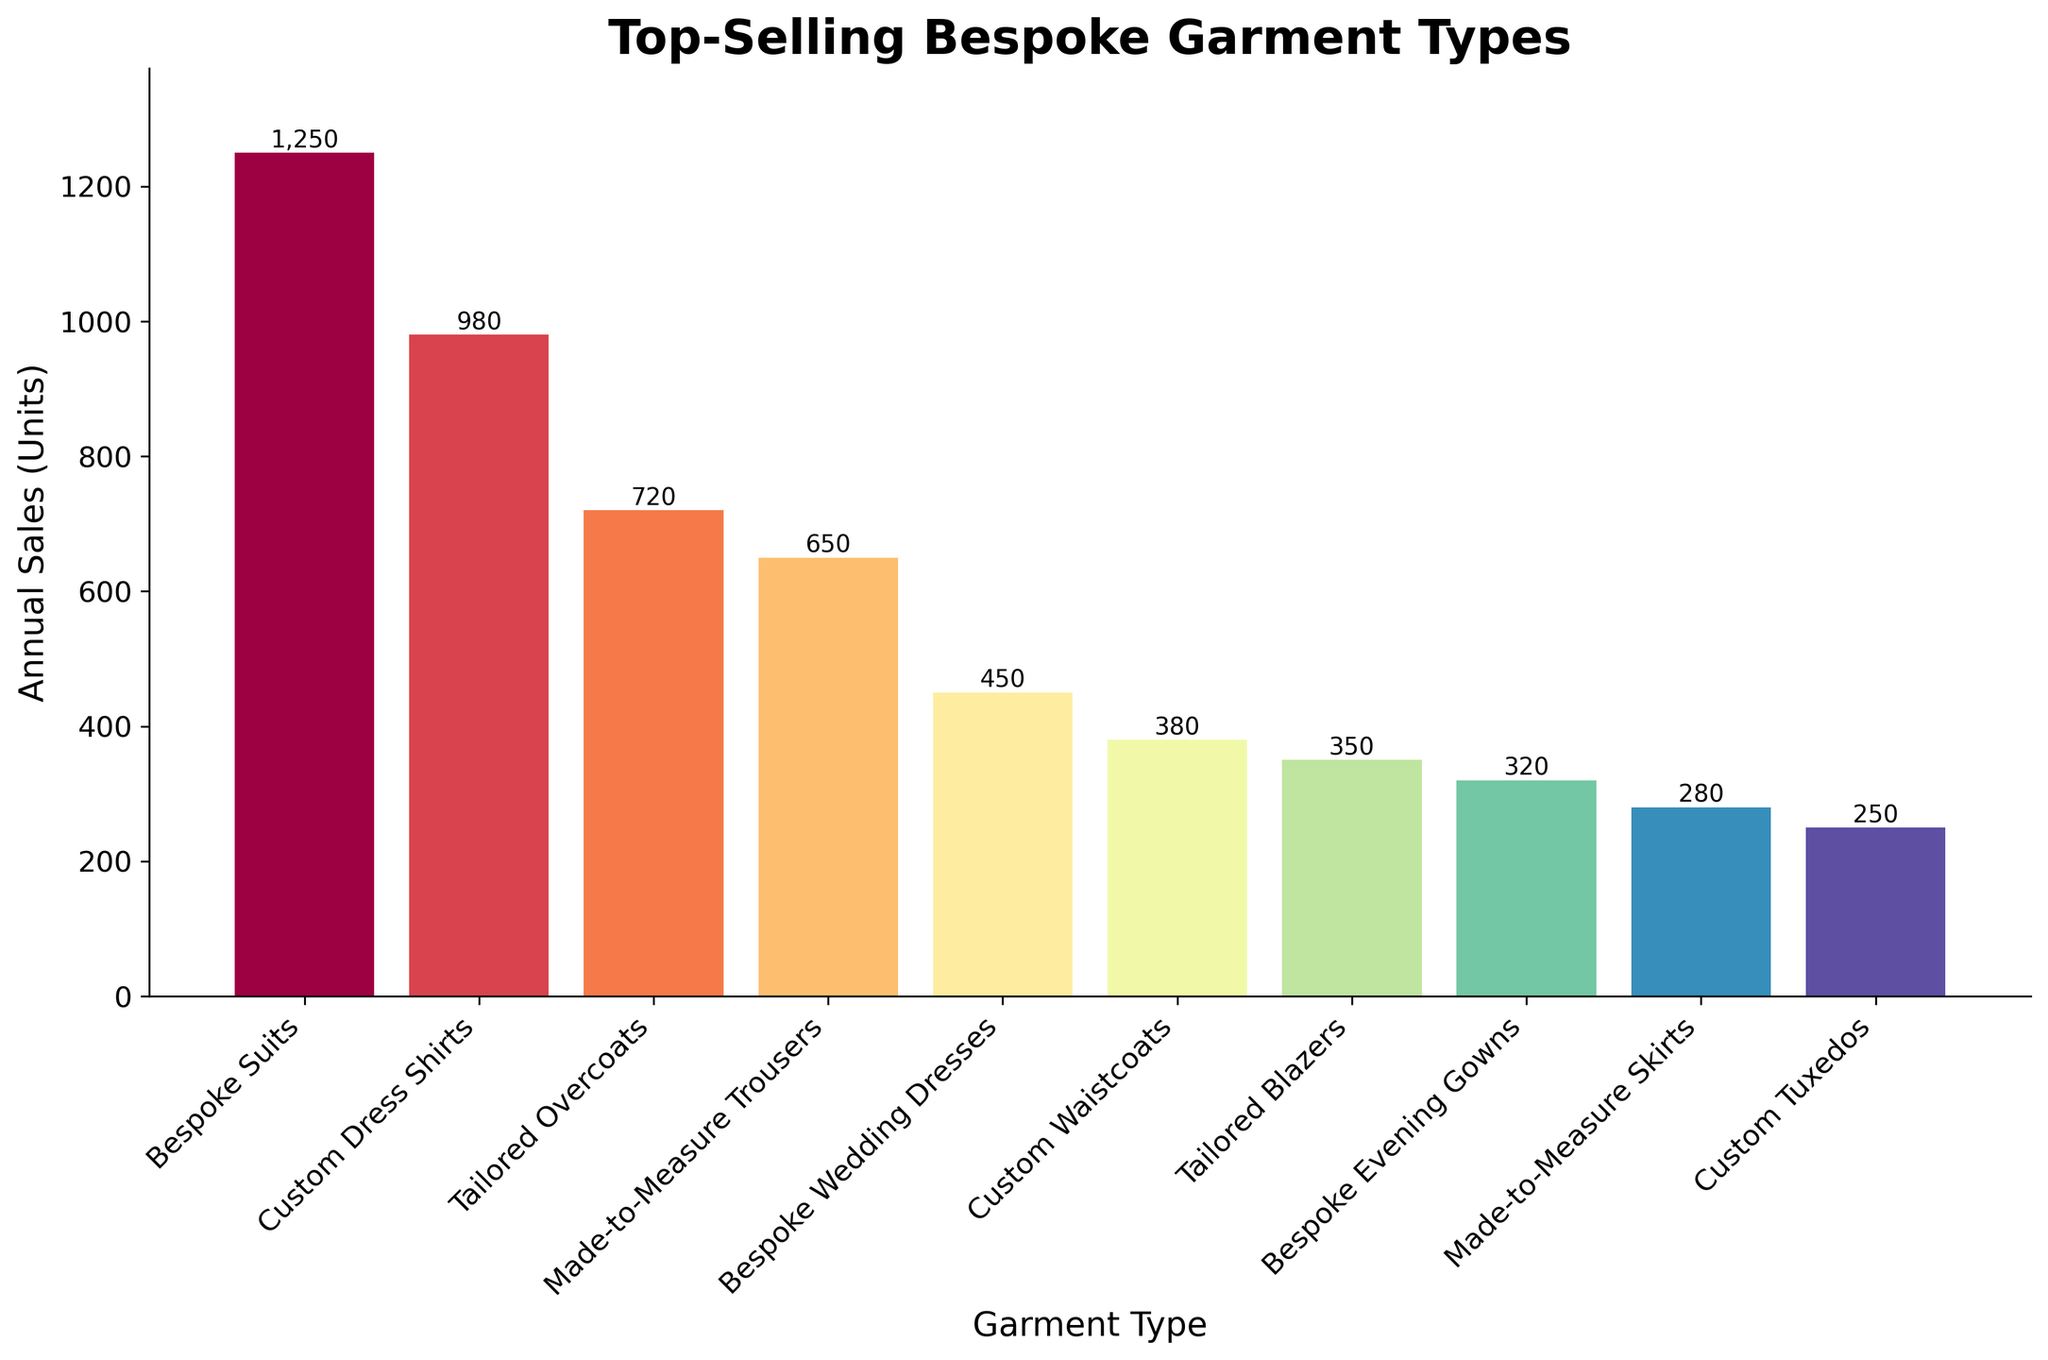Which garment type has the highest annual sales? To determine which garment type has the highest annual sales, look for the tallest bar in the bar chart. The tallest bar represents the "Bespoke Suits".
Answer: Bespoke Suits Which garment type has the lowest annual sales? To find the garment type with the lowest annual sales, identify the shortest bar in the bar chart. The shortest bar represents the "Custom Tuxedos".
Answer: Custom Tuxedos How many more units do Bespoke Suits sell than Custom Dress Shirts? To find the difference in sales between Bespoke Suits and Custom Dress Shirts, subtract the annual sales of Custom Dress Shirts from Bespoke Suits. Bespoke Suits: 1250 units, Custom Dress Shirts: 980 units. The difference is 1250 - 980 = 270 units.
Answer: 270 units What is the combined annual sales of Tailored Overcoats and Made-to-Measure Trousers? To find the combined annual sales of Tailored Overcoats and Made-to-Measure Trousers, add their annual sales. Tailored Overcoats: 720 units, Made-to-Measure Trousers: 650 units. The combined sales is 720 + 650 = 1370 units.
Answer: 1370 units Which has higher sales: Custom Waistcoats or Tailored Blazers? Compare the height of the bars for Custom Waistcoats and Tailored Blazers. The bar for Custom Waistcoats is taller than the bar for Tailored Blazers. Custom Waistcoats have 380 units and Tailored Blazers have 350 units.
Answer: Custom Waistcoats What is the sales difference between Bespoke Suits and Bespoke Wedding Dresses? Subtract the annual sales of Bespoke Wedding Dresses from Bespoke Suits. Bespoke Suits: 1250 units, Bespoke Wedding Dresses: 450 units. The difference is 1250 - 450 = 800 units.
Answer: 800 units What is the average annual sales of the three lowest selling garment types? Identify the three lowest selling garment types: Custom Tuxedos (250 units), Made-to-Measure Skirts (280 units), and Bespoke Evening Gowns (320 units). Sum the sales: 250 + 280 + 320 = 850 units. Then divide by 3 to find the average: 850 / 3 ≈ 283.33 units.
Answer: ≈ 283.33 units Which garment type is the third highest in annual sales? Sort the garment types by sales in descending order to find that Tailored Overcoats (720 units) is the third highest. The first highest is Bespoke Suits (1250 units), the second highest is Custom Dress Shirts (980 units), and Tailored Overcoats comes third.
Answer: Tailored Overcoats What is the total annual sales for all the bespoke garment types? To find the total annual sales for all bespoke garment types, sum the sales of all the garment types provided. 1250 + 980 + 720 + 650 + 450 + 380 + 350 + 320 + 280 + 250 = 5630 units.
Answer: 5630 units Is the annual sales of Bespoke Suits more than double the sales of Bespoke Evening Gowns? Compare the annual sales of Bespoke Suits to twice the sales of Bespoke Evening Gowns. Bespoke Suits: 1250 units, Bespoke Evening Gowns: 320 units. Twice the sales of Bespoke Evening Gowns is 2 * 320 = 640 units. 1250 units is more than 640 units.
Answer: Yes 